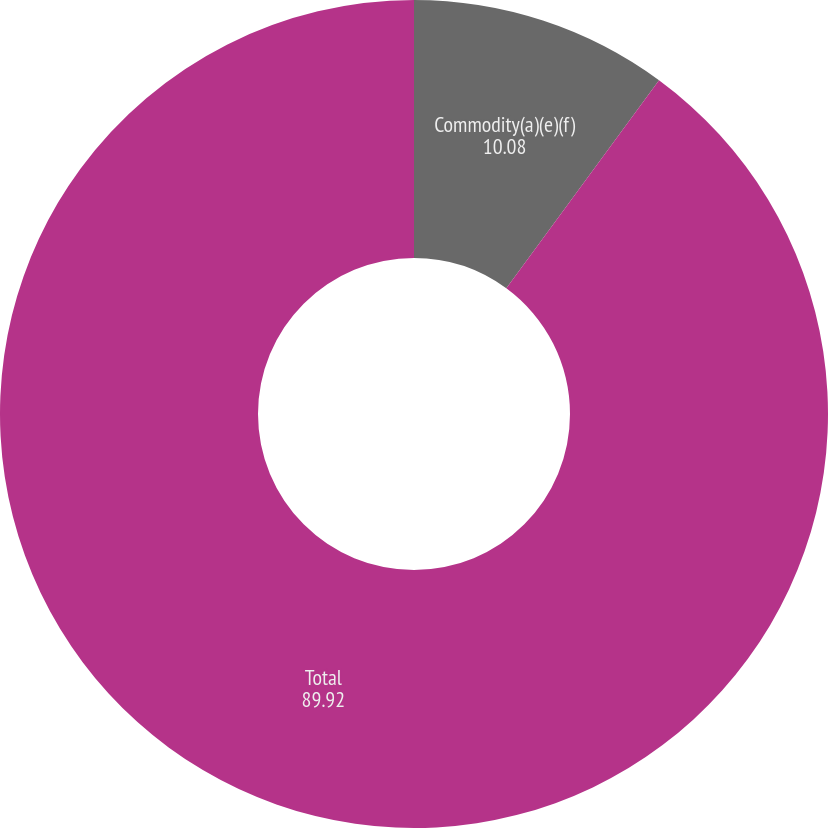Convert chart. <chart><loc_0><loc_0><loc_500><loc_500><pie_chart><fcel>Commodity(a)(e)(f)<fcel>Total<nl><fcel>10.08%<fcel>89.92%<nl></chart> 